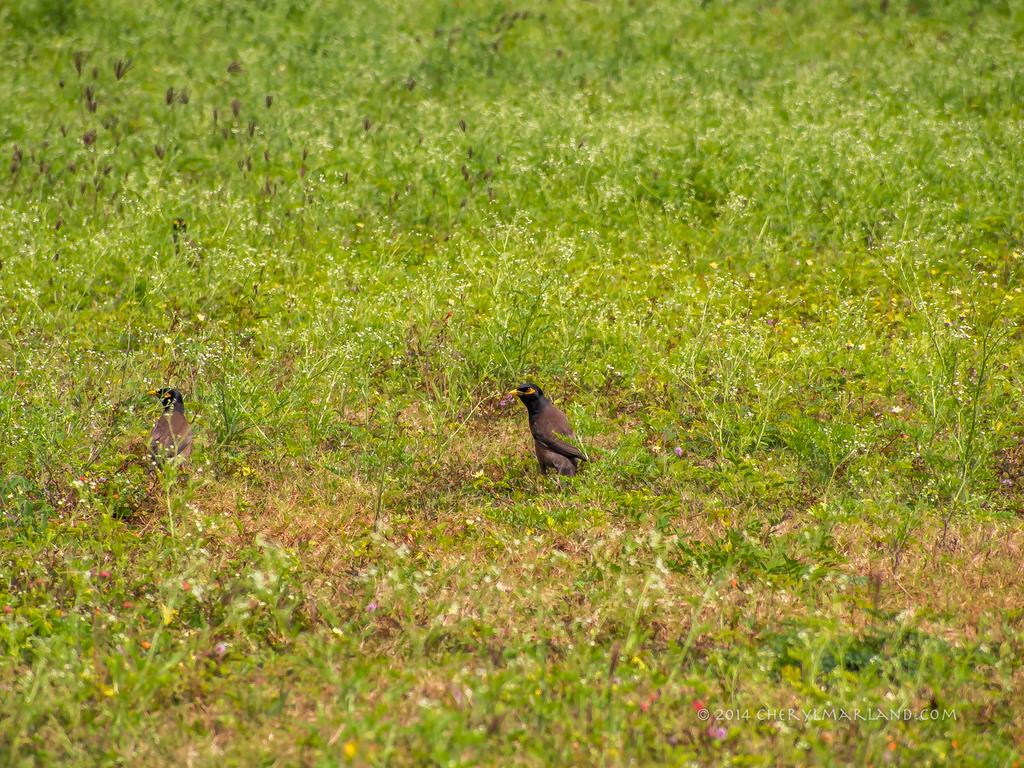How many birds are present in the image? There are two birds in the image. What colors are the birds? The birds are in black and brown color. What can be seen in the background of the image? There are plants and flowers in the background of the image. What color are the plants? The plants are green in color. What colors are the flowers? The flowers are in orange and yellow color. What type of horn can be heard playing in the background of the image? There is no horn or any sound present in the image; it is a still image of birds and plants. Is there a cemetery visible in the image? No, there is no cemetery present in the image; it features birds, plants, and flowers. 